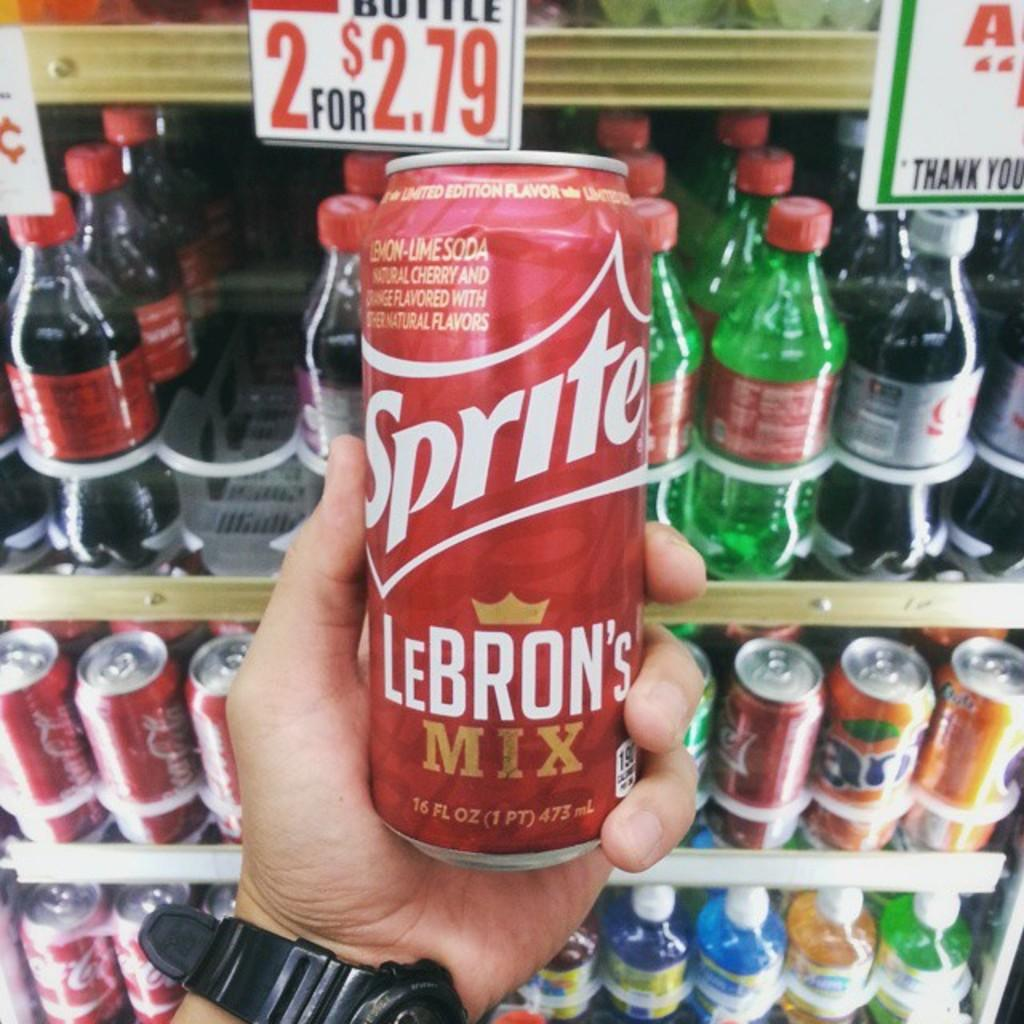Provide a one-sentence caption for the provided image. A man is holding a can of red Sprite. 